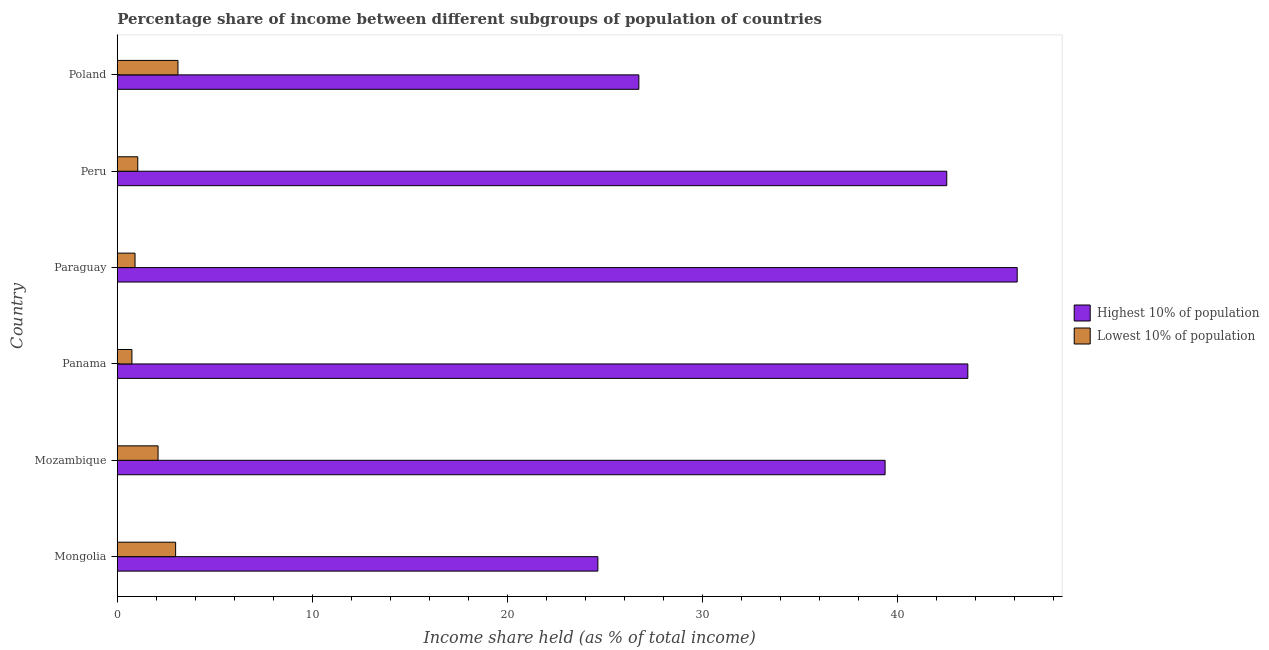Are the number of bars per tick equal to the number of legend labels?
Offer a terse response. Yes. What is the label of the 3rd group of bars from the top?
Provide a short and direct response. Paraguay. In how many cases, is the number of bars for a given country not equal to the number of legend labels?
Make the answer very short. 0. What is the income share held by lowest 10% of the population in Panama?
Make the answer very short. 0.75. Across all countries, what is the maximum income share held by lowest 10% of the population?
Your answer should be very brief. 3.11. Across all countries, what is the minimum income share held by lowest 10% of the population?
Offer a terse response. 0.75. In which country was the income share held by highest 10% of the population maximum?
Keep it short and to the point. Paraguay. In which country was the income share held by lowest 10% of the population minimum?
Your response must be concise. Panama. What is the total income share held by highest 10% of the population in the graph?
Your answer should be very brief. 222.93. What is the difference between the income share held by highest 10% of the population in Mongolia and that in Mozambique?
Your response must be concise. -14.72. What is the difference between the income share held by highest 10% of the population in Panama and the income share held by lowest 10% of the population in Poland?
Offer a very short reply. 40.48. What is the average income share held by lowest 10% of the population per country?
Make the answer very short. 1.82. What is the difference between the income share held by lowest 10% of the population and income share held by highest 10% of the population in Mozambique?
Provide a succinct answer. -37.26. In how many countries, is the income share held by highest 10% of the population greater than 18 %?
Keep it short and to the point. 6. What is the ratio of the income share held by highest 10% of the population in Peru to that in Poland?
Offer a very short reply. 1.59. Is the income share held by highest 10% of the population in Paraguay less than that in Poland?
Keep it short and to the point. No. What is the difference between the highest and the second highest income share held by highest 10% of the population?
Provide a succinct answer. 2.53. What is the difference between the highest and the lowest income share held by lowest 10% of the population?
Your response must be concise. 2.36. In how many countries, is the income share held by highest 10% of the population greater than the average income share held by highest 10% of the population taken over all countries?
Provide a succinct answer. 4. Is the sum of the income share held by highest 10% of the population in Mongolia and Mozambique greater than the maximum income share held by lowest 10% of the population across all countries?
Ensure brevity in your answer.  Yes. What does the 2nd bar from the top in Paraguay represents?
Offer a terse response. Highest 10% of population. What does the 1st bar from the bottom in Poland represents?
Offer a terse response. Highest 10% of population. Are all the bars in the graph horizontal?
Make the answer very short. Yes. How many countries are there in the graph?
Provide a short and direct response. 6. What is the difference between two consecutive major ticks on the X-axis?
Give a very brief answer. 10. Are the values on the major ticks of X-axis written in scientific E-notation?
Provide a succinct answer. No. How many legend labels are there?
Offer a terse response. 2. What is the title of the graph?
Your answer should be compact. Percentage share of income between different subgroups of population of countries. Does "GDP per capita" appear as one of the legend labels in the graph?
Your response must be concise. No. What is the label or title of the X-axis?
Give a very brief answer. Income share held (as % of total income). What is the Income share held (as % of total income) in Highest 10% of population in Mongolia?
Provide a succinct answer. 24.63. What is the Income share held (as % of total income) in Lowest 10% of population in Mongolia?
Make the answer very short. 2.99. What is the Income share held (as % of total income) of Highest 10% of population in Mozambique?
Your answer should be very brief. 39.35. What is the Income share held (as % of total income) in Lowest 10% of population in Mozambique?
Provide a short and direct response. 2.09. What is the Income share held (as % of total income) of Highest 10% of population in Panama?
Give a very brief answer. 43.59. What is the Income share held (as % of total income) in Highest 10% of population in Paraguay?
Offer a terse response. 46.12. What is the Income share held (as % of total income) in Lowest 10% of population in Paraguay?
Provide a short and direct response. 0.91. What is the Income share held (as % of total income) in Highest 10% of population in Peru?
Provide a short and direct response. 42.51. What is the Income share held (as % of total income) in Highest 10% of population in Poland?
Provide a succinct answer. 26.73. What is the Income share held (as % of total income) of Lowest 10% of population in Poland?
Offer a terse response. 3.11. Across all countries, what is the maximum Income share held (as % of total income) in Highest 10% of population?
Provide a succinct answer. 46.12. Across all countries, what is the maximum Income share held (as % of total income) in Lowest 10% of population?
Offer a very short reply. 3.11. Across all countries, what is the minimum Income share held (as % of total income) of Highest 10% of population?
Make the answer very short. 24.63. Across all countries, what is the minimum Income share held (as % of total income) of Lowest 10% of population?
Offer a very short reply. 0.75. What is the total Income share held (as % of total income) in Highest 10% of population in the graph?
Your answer should be very brief. 222.93. What is the difference between the Income share held (as % of total income) of Highest 10% of population in Mongolia and that in Mozambique?
Make the answer very short. -14.72. What is the difference between the Income share held (as % of total income) in Highest 10% of population in Mongolia and that in Panama?
Keep it short and to the point. -18.96. What is the difference between the Income share held (as % of total income) in Lowest 10% of population in Mongolia and that in Panama?
Offer a very short reply. 2.24. What is the difference between the Income share held (as % of total income) in Highest 10% of population in Mongolia and that in Paraguay?
Make the answer very short. -21.49. What is the difference between the Income share held (as % of total income) in Lowest 10% of population in Mongolia and that in Paraguay?
Keep it short and to the point. 2.08. What is the difference between the Income share held (as % of total income) of Highest 10% of population in Mongolia and that in Peru?
Provide a short and direct response. -17.88. What is the difference between the Income share held (as % of total income) of Lowest 10% of population in Mongolia and that in Peru?
Your response must be concise. 1.94. What is the difference between the Income share held (as % of total income) in Highest 10% of population in Mongolia and that in Poland?
Your response must be concise. -2.1. What is the difference between the Income share held (as % of total income) of Lowest 10% of population in Mongolia and that in Poland?
Provide a succinct answer. -0.12. What is the difference between the Income share held (as % of total income) of Highest 10% of population in Mozambique and that in Panama?
Provide a short and direct response. -4.24. What is the difference between the Income share held (as % of total income) of Lowest 10% of population in Mozambique and that in Panama?
Provide a succinct answer. 1.34. What is the difference between the Income share held (as % of total income) of Highest 10% of population in Mozambique and that in Paraguay?
Keep it short and to the point. -6.77. What is the difference between the Income share held (as % of total income) in Lowest 10% of population in Mozambique and that in Paraguay?
Give a very brief answer. 1.18. What is the difference between the Income share held (as % of total income) in Highest 10% of population in Mozambique and that in Peru?
Provide a short and direct response. -3.16. What is the difference between the Income share held (as % of total income) in Lowest 10% of population in Mozambique and that in Peru?
Your answer should be compact. 1.04. What is the difference between the Income share held (as % of total income) in Highest 10% of population in Mozambique and that in Poland?
Offer a terse response. 12.62. What is the difference between the Income share held (as % of total income) of Lowest 10% of population in Mozambique and that in Poland?
Provide a succinct answer. -1.02. What is the difference between the Income share held (as % of total income) of Highest 10% of population in Panama and that in Paraguay?
Ensure brevity in your answer.  -2.53. What is the difference between the Income share held (as % of total income) of Lowest 10% of population in Panama and that in Paraguay?
Your answer should be compact. -0.16. What is the difference between the Income share held (as % of total income) of Highest 10% of population in Panama and that in Poland?
Keep it short and to the point. 16.86. What is the difference between the Income share held (as % of total income) in Lowest 10% of population in Panama and that in Poland?
Ensure brevity in your answer.  -2.36. What is the difference between the Income share held (as % of total income) of Highest 10% of population in Paraguay and that in Peru?
Ensure brevity in your answer.  3.61. What is the difference between the Income share held (as % of total income) in Lowest 10% of population in Paraguay and that in Peru?
Offer a terse response. -0.14. What is the difference between the Income share held (as % of total income) in Highest 10% of population in Paraguay and that in Poland?
Give a very brief answer. 19.39. What is the difference between the Income share held (as % of total income) of Highest 10% of population in Peru and that in Poland?
Offer a very short reply. 15.78. What is the difference between the Income share held (as % of total income) in Lowest 10% of population in Peru and that in Poland?
Make the answer very short. -2.06. What is the difference between the Income share held (as % of total income) of Highest 10% of population in Mongolia and the Income share held (as % of total income) of Lowest 10% of population in Mozambique?
Your response must be concise. 22.54. What is the difference between the Income share held (as % of total income) in Highest 10% of population in Mongolia and the Income share held (as % of total income) in Lowest 10% of population in Panama?
Give a very brief answer. 23.88. What is the difference between the Income share held (as % of total income) of Highest 10% of population in Mongolia and the Income share held (as % of total income) of Lowest 10% of population in Paraguay?
Ensure brevity in your answer.  23.72. What is the difference between the Income share held (as % of total income) of Highest 10% of population in Mongolia and the Income share held (as % of total income) of Lowest 10% of population in Peru?
Ensure brevity in your answer.  23.58. What is the difference between the Income share held (as % of total income) of Highest 10% of population in Mongolia and the Income share held (as % of total income) of Lowest 10% of population in Poland?
Your answer should be very brief. 21.52. What is the difference between the Income share held (as % of total income) in Highest 10% of population in Mozambique and the Income share held (as % of total income) in Lowest 10% of population in Panama?
Provide a succinct answer. 38.6. What is the difference between the Income share held (as % of total income) of Highest 10% of population in Mozambique and the Income share held (as % of total income) of Lowest 10% of population in Paraguay?
Ensure brevity in your answer.  38.44. What is the difference between the Income share held (as % of total income) of Highest 10% of population in Mozambique and the Income share held (as % of total income) of Lowest 10% of population in Peru?
Give a very brief answer. 38.3. What is the difference between the Income share held (as % of total income) of Highest 10% of population in Mozambique and the Income share held (as % of total income) of Lowest 10% of population in Poland?
Your response must be concise. 36.24. What is the difference between the Income share held (as % of total income) in Highest 10% of population in Panama and the Income share held (as % of total income) in Lowest 10% of population in Paraguay?
Your answer should be very brief. 42.68. What is the difference between the Income share held (as % of total income) of Highest 10% of population in Panama and the Income share held (as % of total income) of Lowest 10% of population in Peru?
Offer a very short reply. 42.54. What is the difference between the Income share held (as % of total income) in Highest 10% of population in Panama and the Income share held (as % of total income) in Lowest 10% of population in Poland?
Keep it short and to the point. 40.48. What is the difference between the Income share held (as % of total income) in Highest 10% of population in Paraguay and the Income share held (as % of total income) in Lowest 10% of population in Peru?
Give a very brief answer. 45.07. What is the difference between the Income share held (as % of total income) in Highest 10% of population in Paraguay and the Income share held (as % of total income) in Lowest 10% of population in Poland?
Make the answer very short. 43.01. What is the difference between the Income share held (as % of total income) of Highest 10% of population in Peru and the Income share held (as % of total income) of Lowest 10% of population in Poland?
Your response must be concise. 39.4. What is the average Income share held (as % of total income) in Highest 10% of population per country?
Ensure brevity in your answer.  37.16. What is the average Income share held (as % of total income) of Lowest 10% of population per country?
Offer a terse response. 1.82. What is the difference between the Income share held (as % of total income) in Highest 10% of population and Income share held (as % of total income) in Lowest 10% of population in Mongolia?
Your answer should be compact. 21.64. What is the difference between the Income share held (as % of total income) in Highest 10% of population and Income share held (as % of total income) in Lowest 10% of population in Mozambique?
Your answer should be compact. 37.26. What is the difference between the Income share held (as % of total income) of Highest 10% of population and Income share held (as % of total income) of Lowest 10% of population in Panama?
Offer a very short reply. 42.84. What is the difference between the Income share held (as % of total income) of Highest 10% of population and Income share held (as % of total income) of Lowest 10% of population in Paraguay?
Provide a short and direct response. 45.21. What is the difference between the Income share held (as % of total income) of Highest 10% of population and Income share held (as % of total income) of Lowest 10% of population in Peru?
Provide a short and direct response. 41.46. What is the difference between the Income share held (as % of total income) of Highest 10% of population and Income share held (as % of total income) of Lowest 10% of population in Poland?
Keep it short and to the point. 23.62. What is the ratio of the Income share held (as % of total income) in Highest 10% of population in Mongolia to that in Mozambique?
Your answer should be very brief. 0.63. What is the ratio of the Income share held (as % of total income) in Lowest 10% of population in Mongolia to that in Mozambique?
Your answer should be compact. 1.43. What is the ratio of the Income share held (as % of total income) in Highest 10% of population in Mongolia to that in Panama?
Provide a succinct answer. 0.56. What is the ratio of the Income share held (as % of total income) in Lowest 10% of population in Mongolia to that in Panama?
Ensure brevity in your answer.  3.99. What is the ratio of the Income share held (as % of total income) in Highest 10% of population in Mongolia to that in Paraguay?
Give a very brief answer. 0.53. What is the ratio of the Income share held (as % of total income) in Lowest 10% of population in Mongolia to that in Paraguay?
Make the answer very short. 3.29. What is the ratio of the Income share held (as % of total income) in Highest 10% of population in Mongolia to that in Peru?
Your response must be concise. 0.58. What is the ratio of the Income share held (as % of total income) in Lowest 10% of population in Mongolia to that in Peru?
Offer a terse response. 2.85. What is the ratio of the Income share held (as % of total income) of Highest 10% of population in Mongolia to that in Poland?
Make the answer very short. 0.92. What is the ratio of the Income share held (as % of total income) of Lowest 10% of population in Mongolia to that in Poland?
Keep it short and to the point. 0.96. What is the ratio of the Income share held (as % of total income) in Highest 10% of population in Mozambique to that in Panama?
Provide a short and direct response. 0.9. What is the ratio of the Income share held (as % of total income) in Lowest 10% of population in Mozambique to that in Panama?
Provide a short and direct response. 2.79. What is the ratio of the Income share held (as % of total income) in Highest 10% of population in Mozambique to that in Paraguay?
Keep it short and to the point. 0.85. What is the ratio of the Income share held (as % of total income) in Lowest 10% of population in Mozambique to that in Paraguay?
Your answer should be very brief. 2.3. What is the ratio of the Income share held (as % of total income) in Highest 10% of population in Mozambique to that in Peru?
Make the answer very short. 0.93. What is the ratio of the Income share held (as % of total income) of Lowest 10% of population in Mozambique to that in Peru?
Provide a succinct answer. 1.99. What is the ratio of the Income share held (as % of total income) in Highest 10% of population in Mozambique to that in Poland?
Provide a short and direct response. 1.47. What is the ratio of the Income share held (as % of total income) in Lowest 10% of population in Mozambique to that in Poland?
Your response must be concise. 0.67. What is the ratio of the Income share held (as % of total income) of Highest 10% of population in Panama to that in Paraguay?
Your answer should be compact. 0.95. What is the ratio of the Income share held (as % of total income) of Lowest 10% of population in Panama to that in Paraguay?
Your response must be concise. 0.82. What is the ratio of the Income share held (as % of total income) in Highest 10% of population in Panama to that in Peru?
Ensure brevity in your answer.  1.03. What is the ratio of the Income share held (as % of total income) of Highest 10% of population in Panama to that in Poland?
Keep it short and to the point. 1.63. What is the ratio of the Income share held (as % of total income) of Lowest 10% of population in Panama to that in Poland?
Your answer should be compact. 0.24. What is the ratio of the Income share held (as % of total income) of Highest 10% of population in Paraguay to that in Peru?
Provide a short and direct response. 1.08. What is the ratio of the Income share held (as % of total income) in Lowest 10% of population in Paraguay to that in Peru?
Provide a short and direct response. 0.87. What is the ratio of the Income share held (as % of total income) in Highest 10% of population in Paraguay to that in Poland?
Your response must be concise. 1.73. What is the ratio of the Income share held (as % of total income) of Lowest 10% of population in Paraguay to that in Poland?
Your answer should be very brief. 0.29. What is the ratio of the Income share held (as % of total income) in Highest 10% of population in Peru to that in Poland?
Ensure brevity in your answer.  1.59. What is the ratio of the Income share held (as % of total income) of Lowest 10% of population in Peru to that in Poland?
Your response must be concise. 0.34. What is the difference between the highest and the second highest Income share held (as % of total income) of Highest 10% of population?
Keep it short and to the point. 2.53. What is the difference between the highest and the second highest Income share held (as % of total income) of Lowest 10% of population?
Offer a very short reply. 0.12. What is the difference between the highest and the lowest Income share held (as % of total income) in Highest 10% of population?
Offer a very short reply. 21.49. What is the difference between the highest and the lowest Income share held (as % of total income) of Lowest 10% of population?
Give a very brief answer. 2.36. 